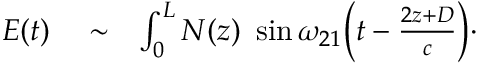Convert formula to latex. <formula><loc_0><loc_0><loc_500><loc_500>\begin{array} { r l r } { E ( t ) } & \sim } & { \int _ { 0 } ^ { L } N ( z ) \ \sin \omega _ { 2 1 } \left ( t - \frac { 2 z + D } { c } \right ) \cdot } \end{array}</formula> 